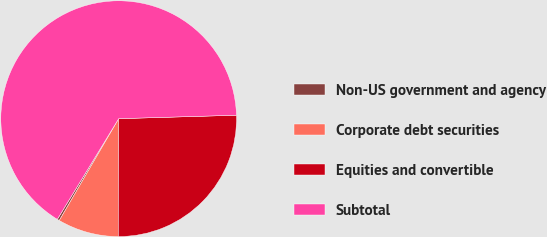<chart> <loc_0><loc_0><loc_500><loc_500><pie_chart><fcel>Non-US government and agency<fcel>Corporate debt securities<fcel>Equities and convertible<fcel>Subtotal<nl><fcel>0.31%<fcel>8.35%<fcel>25.52%<fcel>65.82%<nl></chart> 